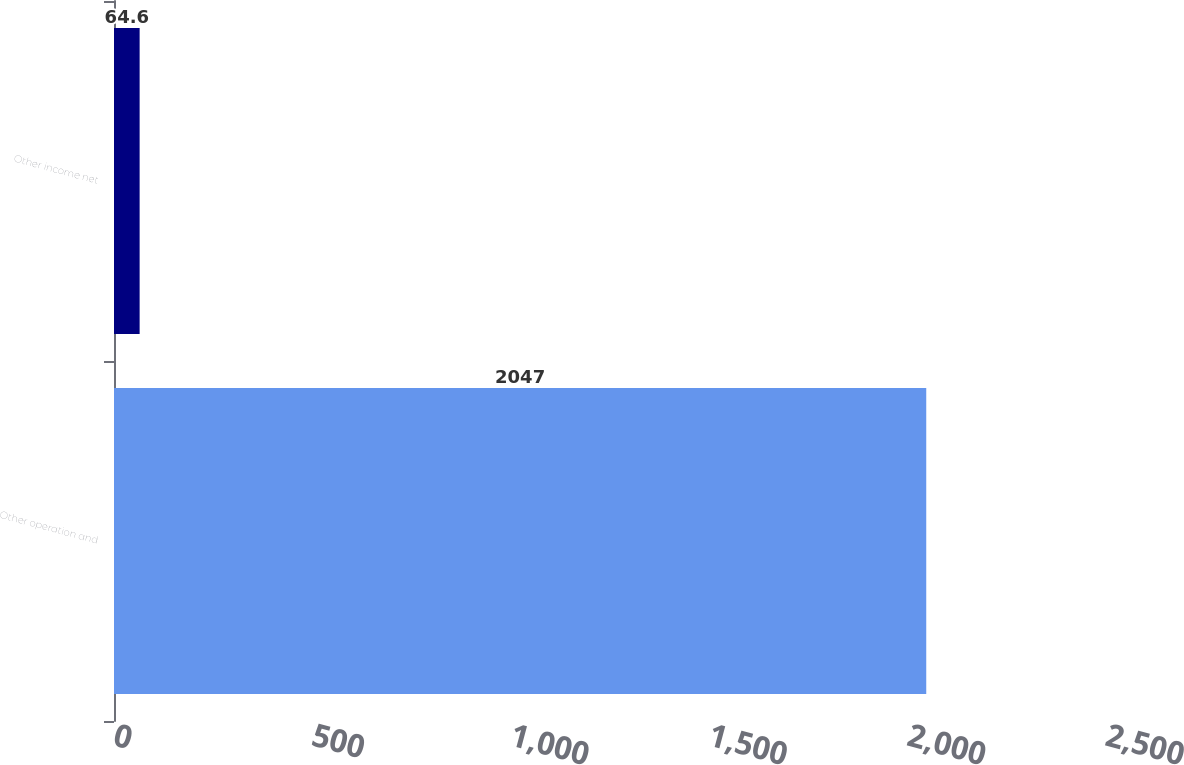Convert chart. <chart><loc_0><loc_0><loc_500><loc_500><bar_chart><fcel>Other operation and<fcel>Other income net<nl><fcel>2047<fcel>64.6<nl></chart> 